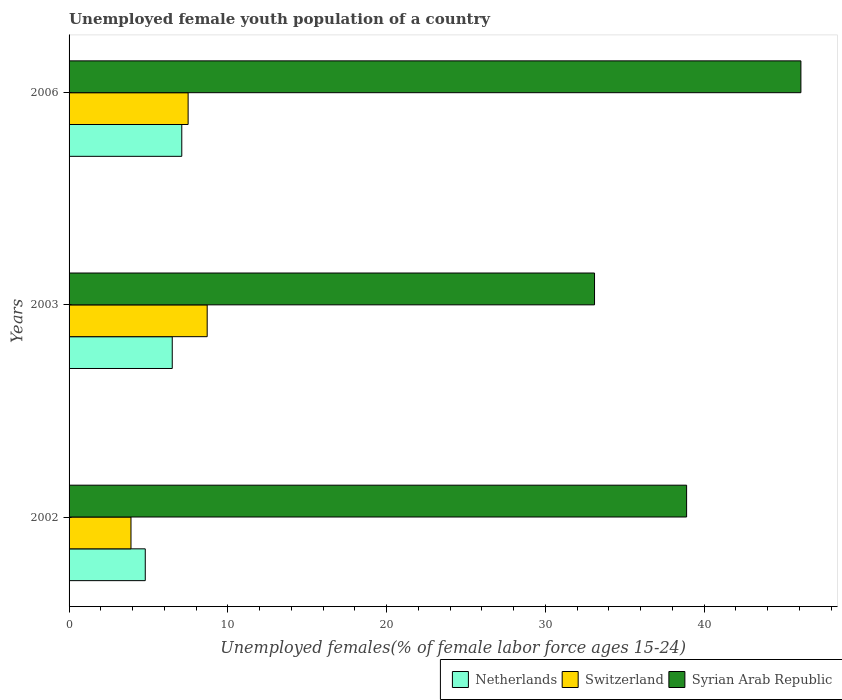How many groups of bars are there?
Ensure brevity in your answer.  3. Are the number of bars per tick equal to the number of legend labels?
Keep it short and to the point. Yes. In how many cases, is the number of bars for a given year not equal to the number of legend labels?
Offer a very short reply. 0. Across all years, what is the maximum percentage of unemployed female youth population in Switzerland?
Make the answer very short. 8.7. Across all years, what is the minimum percentage of unemployed female youth population in Syrian Arab Republic?
Make the answer very short. 33.1. In which year was the percentage of unemployed female youth population in Switzerland minimum?
Your response must be concise. 2002. What is the total percentage of unemployed female youth population in Netherlands in the graph?
Keep it short and to the point. 18.4. What is the difference between the percentage of unemployed female youth population in Syrian Arab Republic in 2002 and that in 2003?
Your answer should be very brief. 5.8. What is the difference between the percentage of unemployed female youth population in Netherlands in 2006 and the percentage of unemployed female youth population in Switzerland in 2002?
Ensure brevity in your answer.  3.2. What is the average percentage of unemployed female youth population in Netherlands per year?
Offer a terse response. 6.13. In the year 2002, what is the difference between the percentage of unemployed female youth population in Syrian Arab Republic and percentage of unemployed female youth population in Switzerland?
Give a very brief answer. 35. In how many years, is the percentage of unemployed female youth population in Netherlands greater than 44 %?
Keep it short and to the point. 0. What is the ratio of the percentage of unemployed female youth population in Netherlands in 2002 to that in 2003?
Your response must be concise. 0.74. Is the percentage of unemployed female youth population in Netherlands in 2003 less than that in 2006?
Keep it short and to the point. Yes. Is the difference between the percentage of unemployed female youth population in Syrian Arab Republic in 2003 and 2006 greater than the difference between the percentage of unemployed female youth population in Switzerland in 2003 and 2006?
Ensure brevity in your answer.  No. What is the difference between the highest and the second highest percentage of unemployed female youth population in Switzerland?
Your answer should be compact. 1.2. What is the difference between the highest and the lowest percentage of unemployed female youth population in Netherlands?
Your answer should be very brief. 2.3. What does the 1st bar from the top in 2006 represents?
Offer a very short reply. Syrian Arab Republic. What does the 3rd bar from the bottom in 2003 represents?
Make the answer very short. Syrian Arab Republic. Is it the case that in every year, the sum of the percentage of unemployed female youth population in Switzerland and percentage of unemployed female youth population in Syrian Arab Republic is greater than the percentage of unemployed female youth population in Netherlands?
Ensure brevity in your answer.  Yes. Are all the bars in the graph horizontal?
Offer a terse response. Yes. How many years are there in the graph?
Keep it short and to the point. 3. Does the graph contain any zero values?
Offer a terse response. No. Does the graph contain grids?
Offer a very short reply. No. How many legend labels are there?
Offer a very short reply. 3. How are the legend labels stacked?
Your answer should be compact. Horizontal. What is the title of the graph?
Offer a terse response. Unemployed female youth population of a country. What is the label or title of the X-axis?
Make the answer very short. Unemployed females(% of female labor force ages 15-24). What is the label or title of the Y-axis?
Your response must be concise. Years. What is the Unemployed females(% of female labor force ages 15-24) of Netherlands in 2002?
Provide a short and direct response. 4.8. What is the Unemployed females(% of female labor force ages 15-24) in Switzerland in 2002?
Ensure brevity in your answer.  3.9. What is the Unemployed females(% of female labor force ages 15-24) of Syrian Arab Republic in 2002?
Offer a very short reply. 38.9. What is the Unemployed females(% of female labor force ages 15-24) in Switzerland in 2003?
Offer a terse response. 8.7. What is the Unemployed females(% of female labor force ages 15-24) of Syrian Arab Republic in 2003?
Offer a very short reply. 33.1. What is the Unemployed females(% of female labor force ages 15-24) in Netherlands in 2006?
Offer a very short reply. 7.1. What is the Unemployed females(% of female labor force ages 15-24) in Syrian Arab Republic in 2006?
Make the answer very short. 46.1. Across all years, what is the maximum Unemployed females(% of female labor force ages 15-24) of Netherlands?
Your response must be concise. 7.1. Across all years, what is the maximum Unemployed females(% of female labor force ages 15-24) of Switzerland?
Give a very brief answer. 8.7. Across all years, what is the maximum Unemployed females(% of female labor force ages 15-24) of Syrian Arab Republic?
Provide a short and direct response. 46.1. Across all years, what is the minimum Unemployed females(% of female labor force ages 15-24) of Netherlands?
Keep it short and to the point. 4.8. Across all years, what is the minimum Unemployed females(% of female labor force ages 15-24) in Switzerland?
Provide a short and direct response. 3.9. Across all years, what is the minimum Unemployed females(% of female labor force ages 15-24) in Syrian Arab Republic?
Make the answer very short. 33.1. What is the total Unemployed females(% of female labor force ages 15-24) of Netherlands in the graph?
Provide a succinct answer. 18.4. What is the total Unemployed females(% of female labor force ages 15-24) in Switzerland in the graph?
Offer a terse response. 20.1. What is the total Unemployed females(% of female labor force ages 15-24) of Syrian Arab Republic in the graph?
Provide a short and direct response. 118.1. What is the difference between the Unemployed females(% of female labor force ages 15-24) of Switzerland in 2002 and that in 2003?
Your answer should be very brief. -4.8. What is the difference between the Unemployed females(% of female labor force ages 15-24) of Syrian Arab Republic in 2002 and that in 2003?
Your response must be concise. 5.8. What is the difference between the Unemployed females(% of female labor force ages 15-24) of Syrian Arab Republic in 2002 and that in 2006?
Offer a terse response. -7.2. What is the difference between the Unemployed females(% of female labor force ages 15-24) in Netherlands in 2003 and that in 2006?
Your response must be concise. -0.6. What is the difference between the Unemployed females(% of female labor force ages 15-24) in Switzerland in 2003 and that in 2006?
Your response must be concise. 1.2. What is the difference between the Unemployed females(% of female labor force ages 15-24) in Syrian Arab Republic in 2003 and that in 2006?
Your response must be concise. -13. What is the difference between the Unemployed females(% of female labor force ages 15-24) in Netherlands in 2002 and the Unemployed females(% of female labor force ages 15-24) in Switzerland in 2003?
Provide a short and direct response. -3.9. What is the difference between the Unemployed females(% of female labor force ages 15-24) in Netherlands in 2002 and the Unemployed females(% of female labor force ages 15-24) in Syrian Arab Republic in 2003?
Your response must be concise. -28.3. What is the difference between the Unemployed females(% of female labor force ages 15-24) in Switzerland in 2002 and the Unemployed females(% of female labor force ages 15-24) in Syrian Arab Republic in 2003?
Your response must be concise. -29.2. What is the difference between the Unemployed females(% of female labor force ages 15-24) in Netherlands in 2002 and the Unemployed females(% of female labor force ages 15-24) in Switzerland in 2006?
Provide a short and direct response. -2.7. What is the difference between the Unemployed females(% of female labor force ages 15-24) of Netherlands in 2002 and the Unemployed females(% of female labor force ages 15-24) of Syrian Arab Republic in 2006?
Your answer should be compact. -41.3. What is the difference between the Unemployed females(% of female labor force ages 15-24) in Switzerland in 2002 and the Unemployed females(% of female labor force ages 15-24) in Syrian Arab Republic in 2006?
Make the answer very short. -42.2. What is the difference between the Unemployed females(% of female labor force ages 15-24) of Netherlands in 2003 and the Unemployed females(% of female labor force ages 15-24) of Switzerland in 2006?
Give a very brief answer. -1. What is the difference between the Unemployed females(% of female labor force ages 15-24) in Netherlands in 2003 and the Unemployed females(% of female labor force ages 15-24) in Syrian Arab Republic in 2006?
Provide a short and direct response. -39.6. What is the difference between the Unemployed females(% of female labor force ages 15-24) in Switzerland in 2003 and the Unemployed females(% of female labor force ages 15-24) in Syrian Arab Republic in 2006?
Your answer should be very brief. -37.4. What is the average Unemployed females(% of female labor force ages 15-24) in Netherlands per year?
Provide a succinct answer. 6.13. What is the average Unemployed females(% of female labor force ages 15-24) in Syrian Arab Republic per year?
Provide a succinct answer. 39.37. In the year 2002, what is the difference between the Unemployed females(% of female labor force ages 15-24) in Netherlands and Unemployed females(% of female labor force ages 15-24) in Switzerland?
Your response must be concise. 0.9. In the year 2002, what is the difference between the Unemployed females(% of female labor force ages 15-24) of Netherlands and Unemployed females(% of female labor force ages 15-24) of Syrian Arab Republic?
Make the answer very short. -34.1. In the year 2002, what is the difference between the Unemployed females(% of female labor force ages 15-24) of Switzerland and Unemployed females(% of female labor force ages 15-24) of Syrian Arab Republic?
Your answer should be very brief. -35. In the year 2003, what is the difference between the Unemployed females(% of female labor force ages 15-24) in Netherlands and Unemployed females(% of female labor force ages 15-24) in Syrian Arab Republic?
Make the answer very short. -26.6. In the year 2003, what is the difference between the Unemployed females(% of female labor force ages 15-24) of Switzerland and Unemployed females(% of female labor force ages 15-24) of Syrian Arab Republic?
Keep it short and to the point. -24.4. In the year 2006, what is the difference between the Unemployed females(% of female labor force ages 15-24) of Netherlands and Unemployed females(% of female labor force ages 15-24) of Syrian Arab Republic?
Make the answer very short. -39. In the year 2006, what is the difference between the Unemployed females(% of female labor force ages 15-24) of Switzerland and Unemployed females(% of female labor force ages 15-24) of Syrian Arab Republic?
Offer a very short reply. -38.6. What is the ratio of the Unemployed females(% of female labor force ages 15-24) of Netherlands in 2002 to that in 2003?
Your answer should be compact. 0.74. What is the ratio of the Unemployed females(% of female labor force ages 15-24) in Switzerland in 2002 to that in 2003?
Your response must be concise. 0.45. What is the ratio of the Unemployed females(% of female labor force ages 15-24) in Syrian Arab Republic in 2002 to that in 2003?
Offer a terse response. 1.18. What is the ratio of the Unemployed females(% of female labor force ages 15-24) in Netherlands in 2002 to that in 2006?
Your answer should be compact. 0.68. What is the ratio of the Unemployed females(% of female labor force ages 15-24) in Switzerland in 2002 to that in 2006?
Provide a short and direct response. 0.52. What is the ratio of the Unemployed females(% of female labor force ages 15-24) in Syrian Arab Republic in 2002 to that in 2006?
Provide a short and direct response. 0.84. What is the ratio of the Unemployed females(% of female labor force ages 15-24) of Netherlands in 2003 to that in 2006?
Ensure brevity in your answer.  0.92. What is the ratio of the Unemployed females(% of female labor force ages 15-24) of Switzerland in 2003 to that in 2006?
Keep it short and to the point. 1.16. What is the ratio of the Unemployed females(% of female labor force ages 15-24) in Syrian Arab Republic in 2003 to that in 2006?
Offer a very short reply. 0.72. What is the difference between the highest and the second highest Unemployed females(% of female labor force ages 15-24) of Switzerland?
Your answer should be compact. 1.2. What is the difference between the highest and the second highest Unemployed females(% of female labor force ages 15-24) in Syrian Arab Republic?
Ensure brevity in your answer.  7.2. What is the difference between the highest and the lowest Unemployed females(% of female labor force ages 15-24) of Netherlands?
Your answer should be compact. 2.3. 